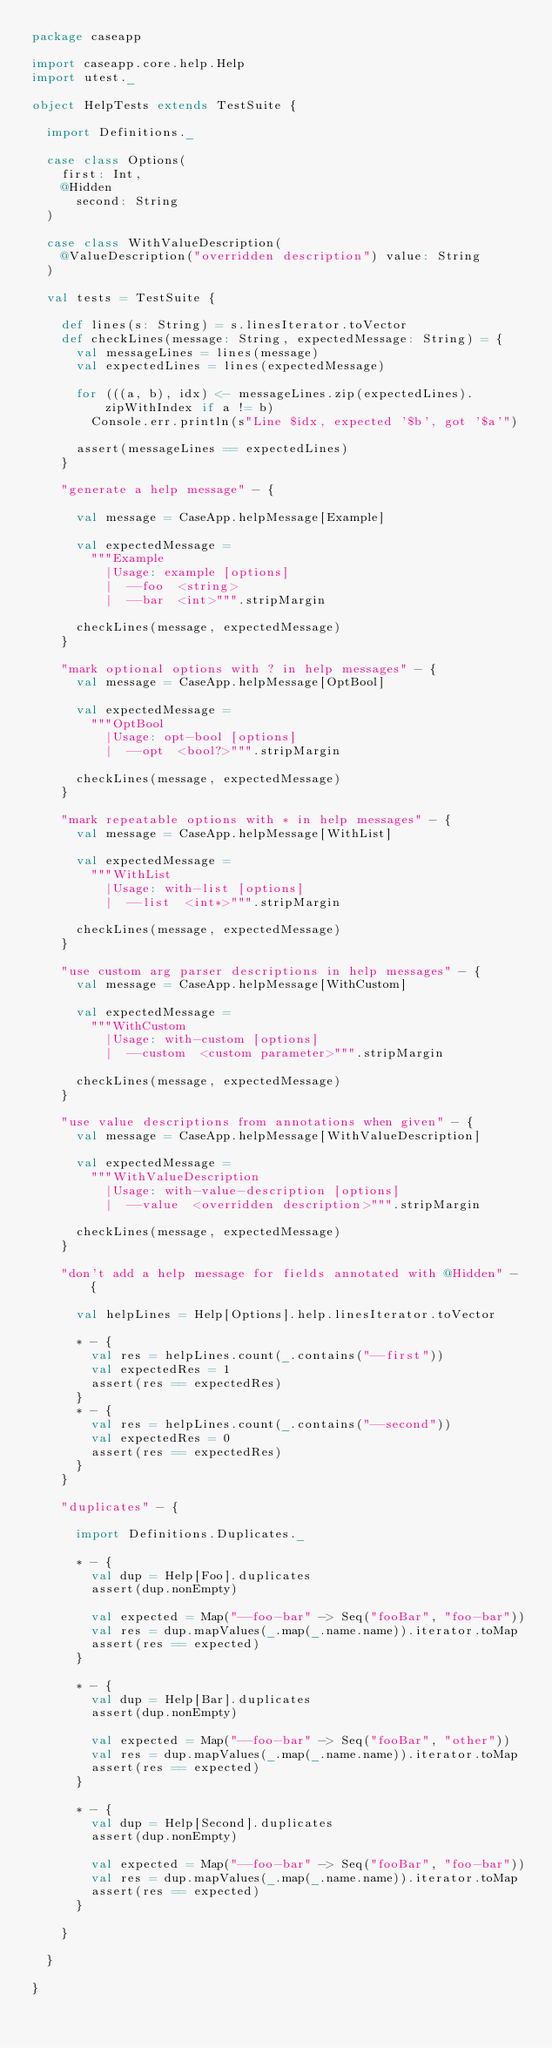<code> <loc_0><loc_0><loc_500><loc_500><_Scala_>package caseapp

import caseapp.core.help.Help
import utest._

object HelpTests extends TestSuite {

  import Definitions._

  case class Options(
    first: Int,
    @Hidden
      second: String
  )

  case class WithValueDescription(
    @ValueDescription("overridden description") value: String
  )

  val tests = TestSuite {

    def lines(s: String) = s.linesIterator.toVector
    def checkLines(message: String, expectedMessage: String) = {
      val messageLines = lines(message)
      val expectedLines = lines(expectedMessage)

      for (((a, b), idx) <- messageLines.zip(expectedLines).zipWithIndex if a != b)
        Console.err.println(s"Line $idx, expected '$b', got '$a'")

      assert(messageLines == expectedLines)
    }

    "generate a help message" - {

      val message = CaseApp.helpMessage[Example]

      val expectedMessage =
        """Example
          |Usage: example [options]
          |  --foo  <string>
          |  --bar  <int>""".stripMargin

      checkLines(message, expectedMessage)
    }

    "mark optional options with ? in help messages" - {
      val message = CaseApp.helpMessage[OptBool]

      val expectedMessage =
        """OptBool
          |Usage: opt-bool [options]
          |  --opt  <bool?>""".stripMargin

      checkLines(message, expectedMessage)
    }

    "mark repeatable options with * in help messages" - {
      val message = CaseApp.helpMessage[WithList]

      val expectedMessage =
        """WithList
          |Usage: with-list [options]
          |  --list  <int*>""".stripMargin

      checkLines(message, expectedMessage)
    }

    "use custom arg parser descriptions in help messages" - {
      val message = CaseApp.helpMessage[WithCustom]

      val expectedMessage =
        """WithCustom
          |Usage: with-custom [options]
          |  --custom  <custom parameter>""".stripMargin

      checkLines(message, expectedMessage)
    }

    "use value descriptions from annotations when given" - {
      val message = CaseApp.helpMessage[WithValueDescription]

      val expectedMessage =
        """WithValueDescription
          |Usage: with-value-description [options]
          |  --value  <overridden description>""".stripMargin

      checkLines(message, expectedMessage)
    }

    "don't add a help message for fields annotated with @Hidden" - {

      val helpLines = Help[Options].help.linesIterator.toVector

      * - {
        val res = helpLines.count(_.contains("--first"))
        val expectedRes = 1
        assert(res == expectedRes)
      }
      * - {
        val res = helpLines.count(_.contains("--second"))
        val expectedRes = 0
        assert(res == expectedRes)
      }
    }

    "duplicates" - {

      import Definitions.Duplicates._

      * - {
        val dup = Help[Foo].duplicates
        assert(dup.nonEmpty)

        val expected = Map("--foo-bar" -> Seq("fooBar", "foo-bar"))
        val res = dup.mapValues(_.map(_.name.name)).iterator.toMap
        assert(res == expected)
      }

      * - {
        val dup = Help[Bar].duplicates
        assert(dup.nonEmpty)

        val expected = Map("--foo-bar" -> Seq("fooBar", "other"))
        val res = dup.mapValues(_.map(_.name.name)).iterator.toMap
        assert(res == expected)
      }

      * - {
        val dup = Help[Second].duplicates
        assert(dup.nonEmpty)

        val expected = Map("--foo-bar" -> Seq("fooBar", "foo-bar"))
        val res = dup.mapValues(_.map(_.name.name)).iterator.toMap
        assert(res == expected)
      }

    }

  }

}
</code> 